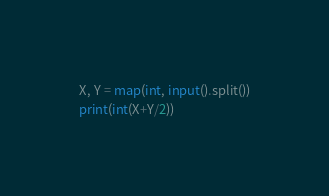Convert code to text. <code><loc_0><loc_0><loc_500><loc_500><_Python_>X, Y = map(int, input().split())
print(int(X+Y/2))</code> 